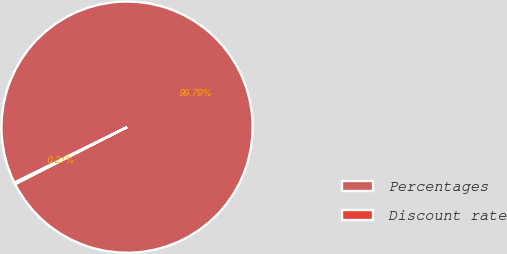Convert chart. <chart><loc_0><loc_0><loc_500><loc_500><pie_chart><fcel>Percentages<fcel>Discount rate<nl><fcel>99.79%<fcel>0.21%<nl></chart> 